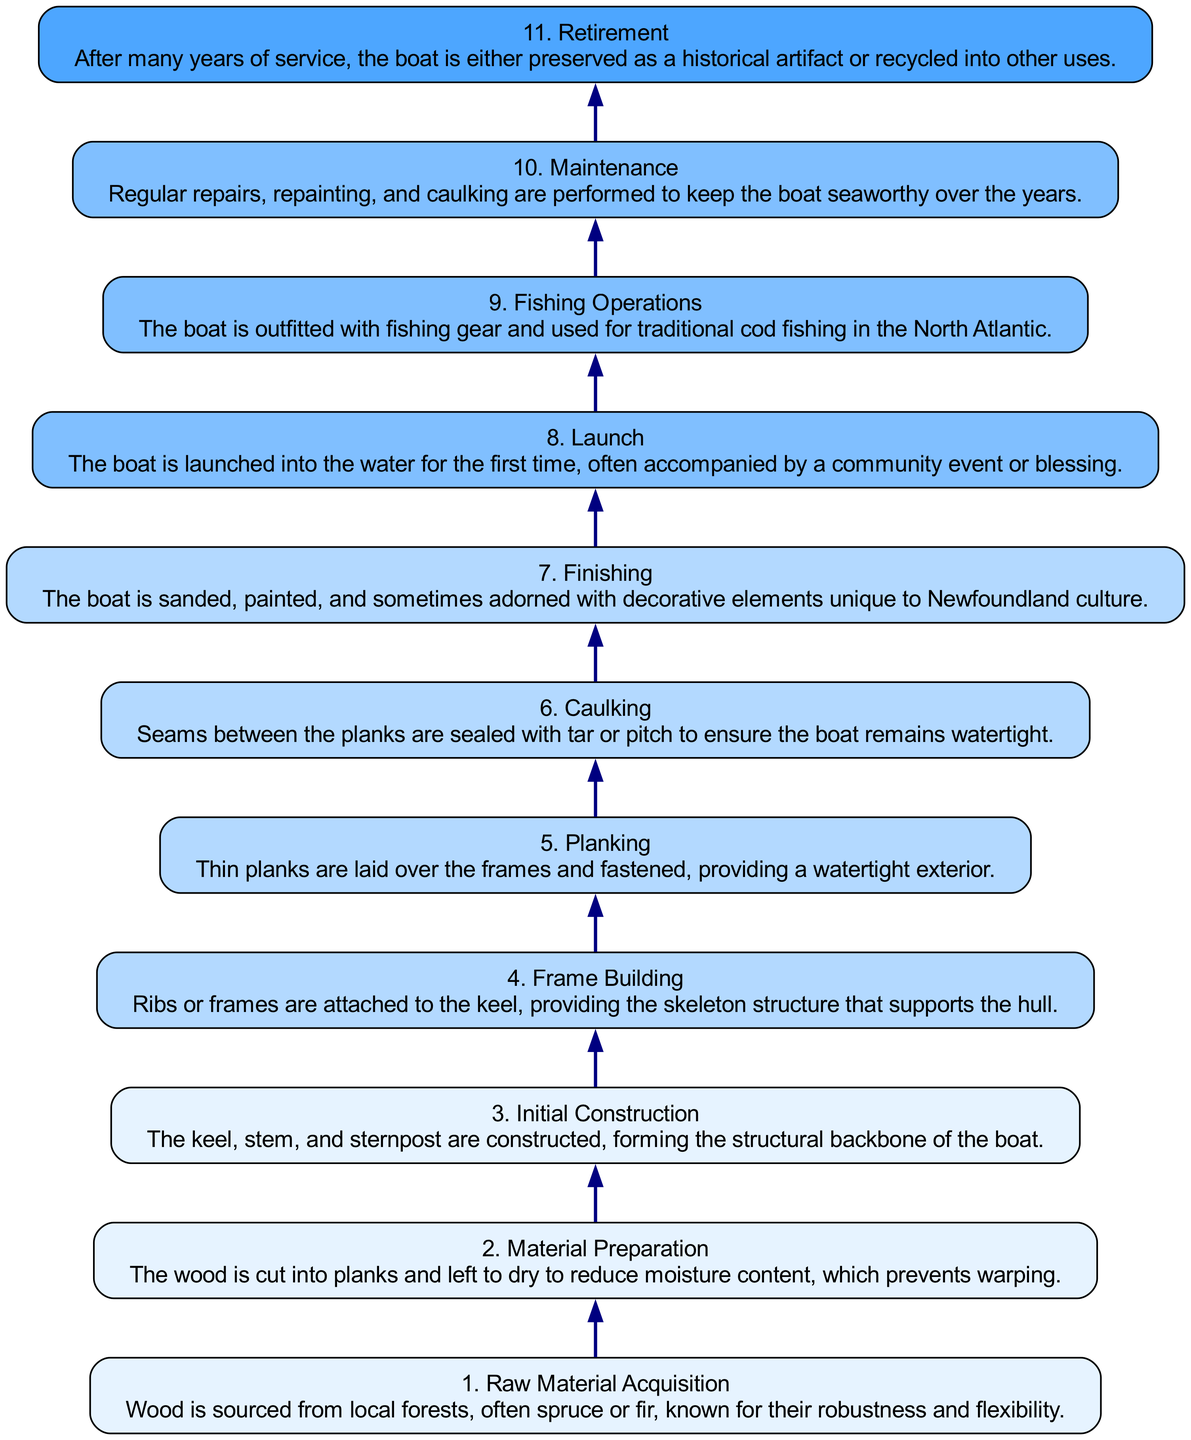What is the first stage in the lifecycle? The first stage in the lifecycle is listed at the bottom of the diagram as "1. Raw Material Acquisition." This indicates that it is the starting point of the process before any subsequent stages occur.
Answer: Raw Material Acquisition How many stages are there? Counting from the bottom to the top of the diagram, there are 11 distinct stages listed, from Raw Material Acquisition to Retirement. Each stage marks a step in the lifecycle, so the total count gives a clear understanding of the entire process.
Answer: 11 What connects Initial Construction and Frame Building? The connection between these two stages is shown by a directed edge pointing from "3. Initial Construction" to "4. Frame Building." This illustrates that Frame Building follows Initial Construction in the lifecycle.
Answer: 3 to 4 Which stage involves decorating the boat? The stage that includes decorating the boat is "7. Finishing." This stage specifically mentions sanding, painting, and adding decorative elements, indicating it is where the boat receives its aesthetic features.
Answer: Finishing What is the last stage of the lifecycle? The last stage is indicated at the top of the diagram as "11. Retirement." This shows that after many years of service, the boat ends its lifecycle either as a preserved artifact or is recycled.
Answer: Retirement Which two stages are directly related to boat maintenance? The stages directly related to maintenance are "10. Maintenance" and "6. Caulking." Maintenance involves general upkeep, while Caulking specifically focuses on ensuring the boat remains watertight, indicating both are crucial for preservation.
Answer: 10 and 6 In what stage is the boat launched? The boat is launched during the "8. Launch" stage. This signifies that it is the point where the construction is completed, and the boat is put into the water for the first time.
Answer: Launch What is necessary before planking can start? Before planking can begin, the stage "4. Frame Building" must occur. Planking relies on the skeleton structure provided by the frames, so this is a prerequisite for laying down the planks.
Answer: Frame Building 